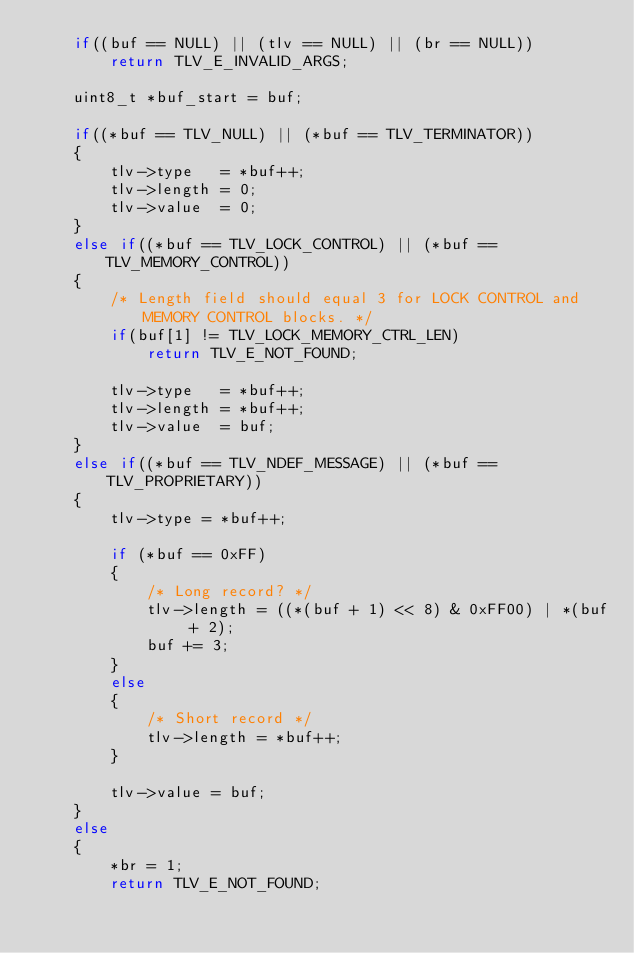Convert code to text. <code><loc_0><loc_0><loc_500><loc_500><_C_>    if((buf == NULL) || (tlv == NULL) || (br == NULL))
        return TLV_E_INVALID_ARGS;

    uint8_t *buf_start = buf;

    if((*buf == TLV_NULL) || (*buf == TLV_TERMINATOR))
    {
        tlv->type   = *buf++;
        tlv->length = 0;
        tlv->value  = 0;            
    }
    else if((*buf == TLV_LOCK_CONTROL) || (*buf == TLV_MEMORY_CONTROL))
    {
        /* Length field should equal 3 for LOCK CONTROL and MEMORY CONTROL blocks. */
        if(buf[1] != TLV_LOCK_MEMORY_CTRL_LEN)
            return TLV_E_NOT_FOUND;

        tlv->type   = *buf++;
        tlv->length = *buf++;
        tlv->value  = buf;
    }
    else if((*buf == TLV_NDEF_MESSAGE) || (*buf == TLV_PROPRIETARY))
    {
        tlv->type = *buf++;

        if (*buf == 0xFF)
        {
            /* Long record? */
            tlv->length = ((*(buf + 1) << 8) & 0xFF00) | *(buf + 2);
            buf += 3;
        }
        else
        {
            /* Short record */
            tlv->length = *buf++;
        }

        tlv->value = buf;
    }
    else
    {
        *br = 1;
        return TLV_E_NOT_FOUND;</code> 